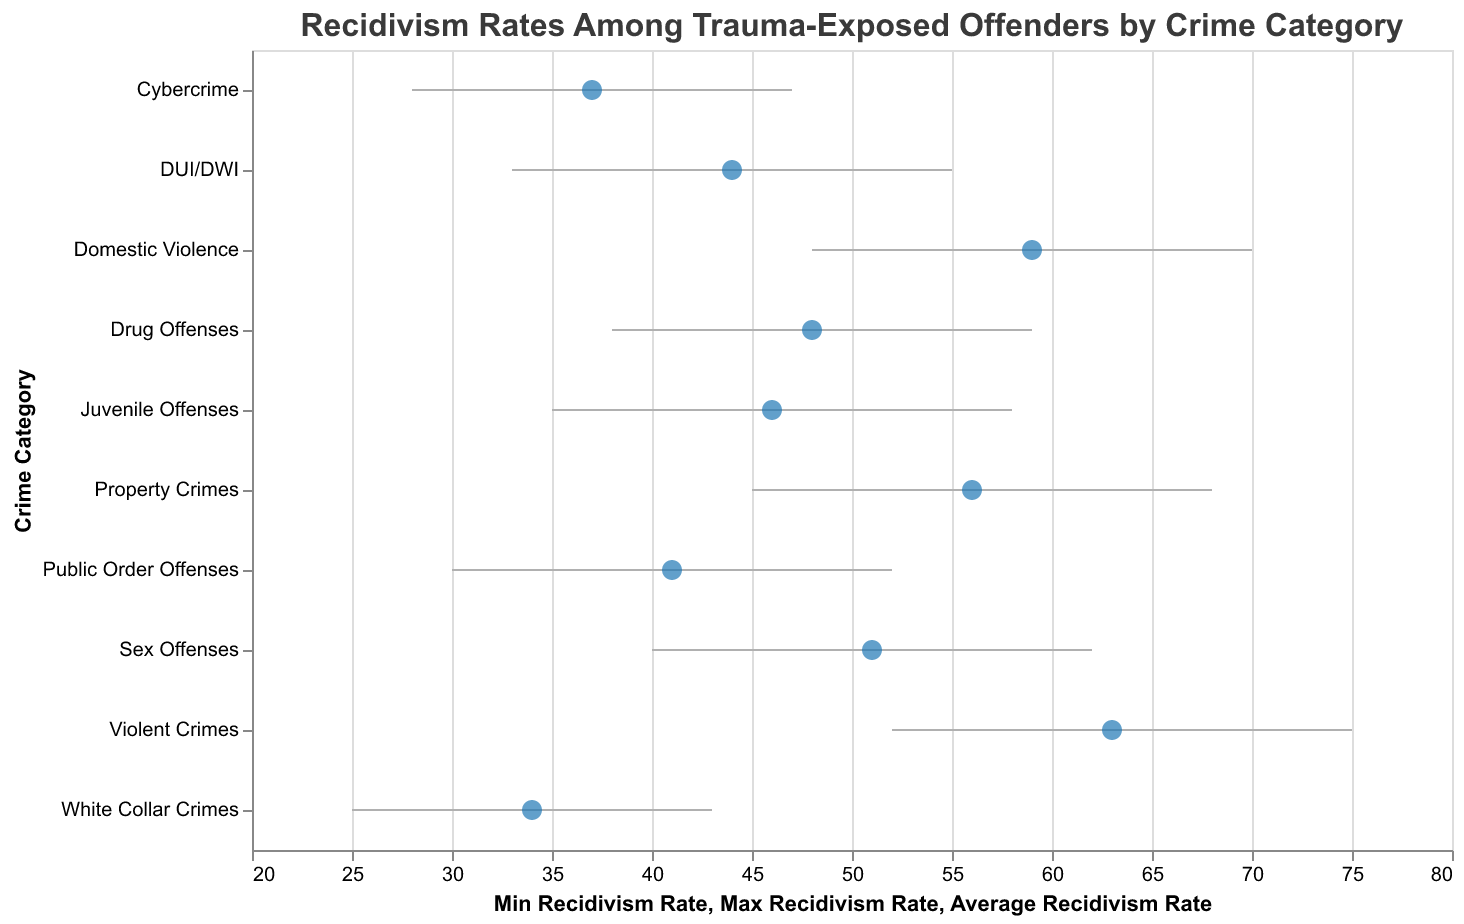What's the title of the figure? The title of the figure is located at the top and is clearly labeled with a larger font size. It states "Recidivism Rates Among Trauma-Exposed Offenders by Crime Category".
Answer: Recidivism Rates Among Trauma-Exposed Offenders by Crime Category Which crime category has the highest average recidivism rate? By looking at the point markers for the average recidivism rate in the figure, the crime category with the highest marker is for "Violent Crimes".
Answer: Violent Crimes What is the minimum recidivism rate for Cybercrime? The minimum recidivism rate is represented by the start of the rule line for each crime category. For Cybercrime, this line starts at 28.
Answer: 28 What is the range of recidivism rates for Public Order Offenses? The range is determined by the difference between the maximum and minimum recidivism rates. For Public Order Offenses, the minimum rate is 30 and the maximum rate is 52. The range is 52 - 30 = 22.
Answer: 22 Which crime category has the smallest range of recidivism rates? The smallest range can be identified by the shortest rule line on the plot. By visual inspection, "White Collar Crimes" has the shortest range from 25 to 43.
Answer: White Collar Crimes How does the average recidivism rate of Domestic Violence compare to Drug Offenses? The average recidivism rates are represented by the points. Domestic Violence has an average rate of 59, and Drug Offenses has an average rate of 48. Therefore, Domestic Violence has a higher average rate than Drug Offenses.
Answer: Domestic Violence has a higher average rate than Drug Offenses Which crime category has an average recidivism rate closest to 50? By locating the point markers closest to the value of 50 on the x-axis, "Sex Offenses" with an average recidivism rate of 51 is the closest.
Answer: Sex Offenses What's the difference between the maximum and average recidivism rate of Domestic Violence? The maximum recidivism rate for Domestic Violence is 70, and the average rate is 59. The difference is 70 - 59 = 11.
Answer: 11 Do any crime categories have a minimum recidivism rate below 30? To determine this, look at the start of the rule lines representing minimum rates. "White Collar Crimes" and "Cybercrime" both start below 30.
Answer: Yes, White Collar Crimes and Cybercrime Which has a greater range, DUI/DWI or Cybercrime? By comparing the lengths of the rule lines, DUI/DWI ranges from 33 to 55, giving a range of 22, and Cybercrime ranges from 28 to 47, giving a range of 19. Therefore, DUI/DWI has a greater range.
Answer: DUI/DWI has a greater range 